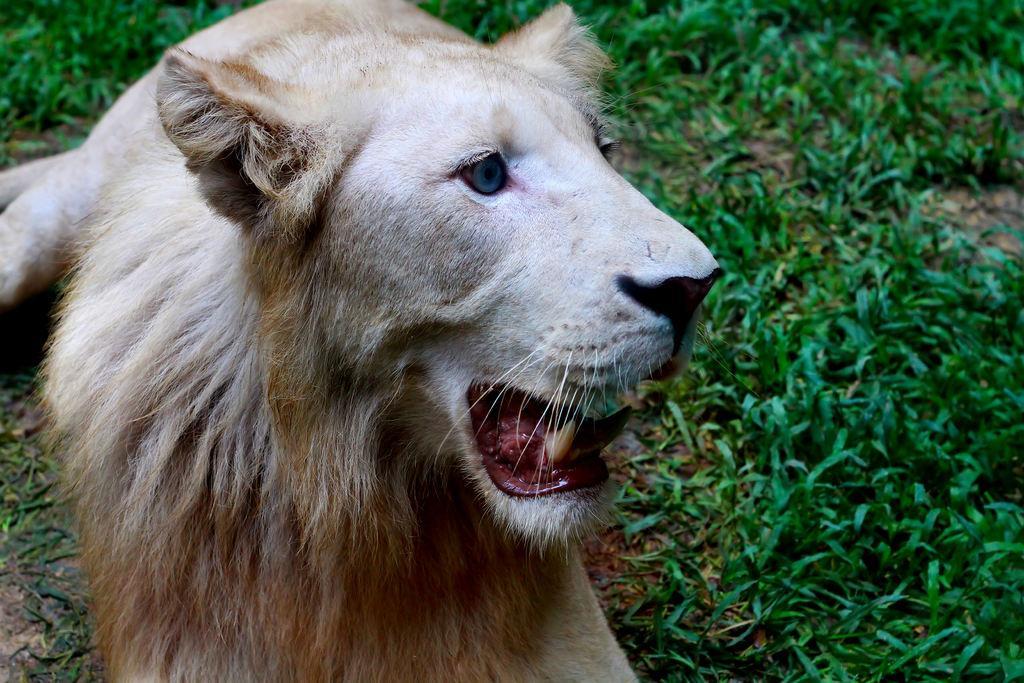Describe this image in one or two sentences. In the image we can see a lion. Behind the lion there is grass. 